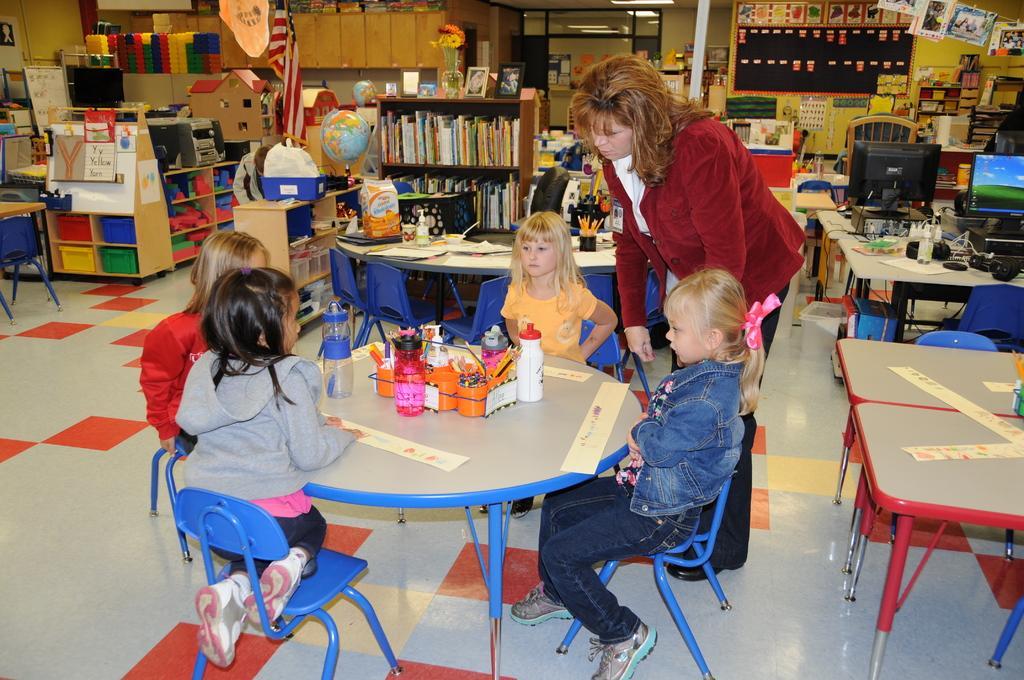Can you describe this image briefly? We can see board over a wall and few posters. We can see books and tubs arranged in a rack. This is a floor. We can see girls sitting on chairs in front of a table and on the table we can see bottles and few products. We can see one woman standing near to the table. 